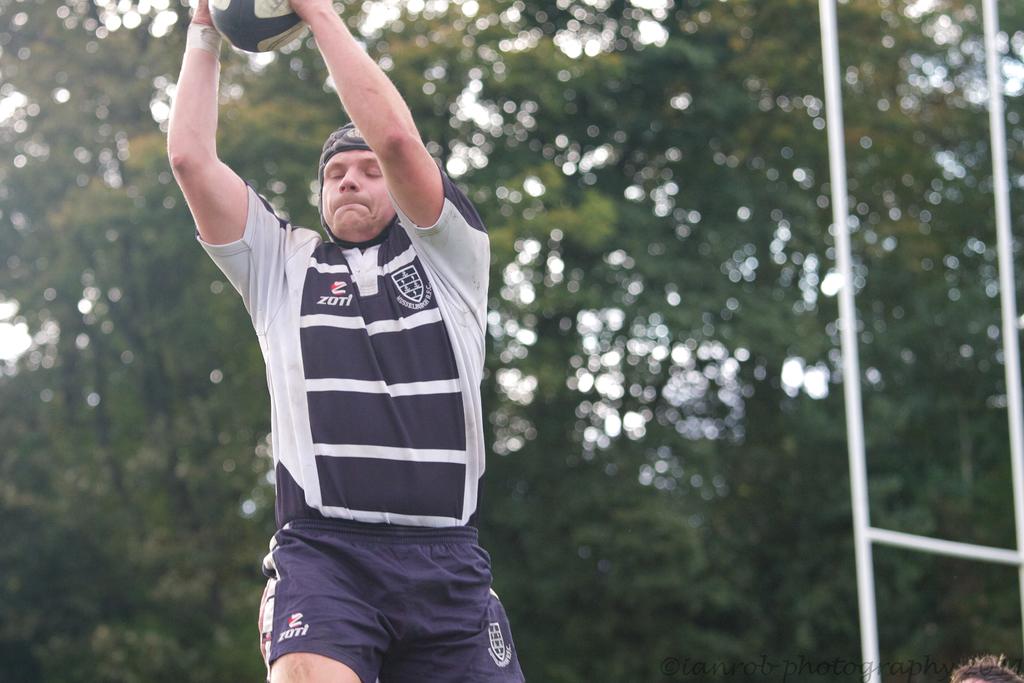What is the name on the shirt and shorts?
Your answer should be compact. Zoti. 